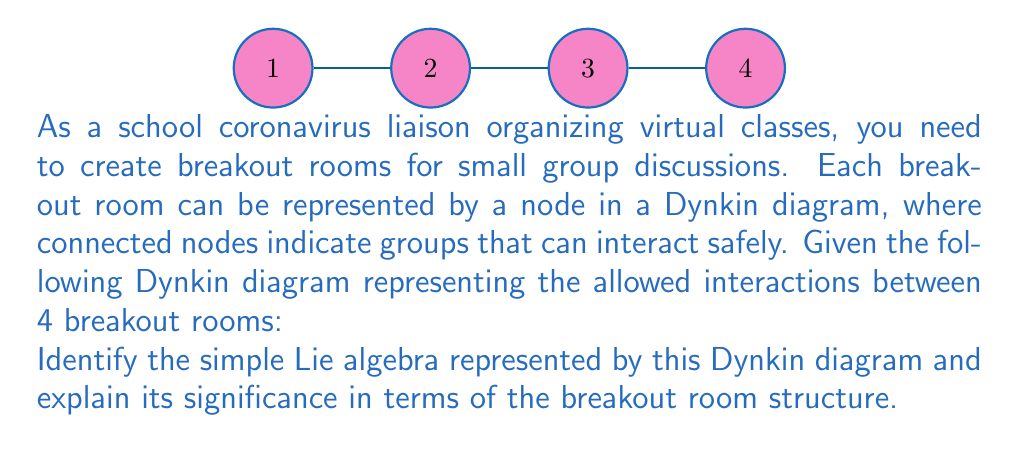Show me your answer to this math problem. To classify the simple Lie algebra using the given Dynkin diagram, we follow these steps:

1) First, we identify the key features of the diagram:
   - It has 4 nodes
   - The nodes are connected in a single line
   - There are no multiple edges or arrows

2) This pattern corresponds to the $A_n$ series of simple Lie algebras, where $n$ is the number of nodes. In this case, we have 4 nodes, so this represents the $A_4$ Lie algebra.

3) The $A_n$ series corresponds to the special linear group $SL(n+1)$ or its Lie algebra $\mathfrak{sl}(n+1)$.

4) In the context of breakout rooms:
   - Each node represents a breakout room
   - Connected nodes indicate rooms that can interact safely
   - The linear structure suggests a chain of safe interactions

5) The $A_4$ structure implies:
   - 5 fundamental representations (4 nodes + 1)
   - A symmetrical structure, where the middle rooms (2 and 3) have more connections than the end rooms (1 and 4)

6) This arrangement allows for controlled, stepwise interactions between groups, which is beneficial for managing social distancing in a virtual classroom setting.

The $A_4$ Lie algebra structure provides a balanced and systematic way to organize breakout rooms, allowing for limited but structured interactions between groups, which aligns well with safety protocols during a pandemic.
Answer: $A_4$ Lie algebra 